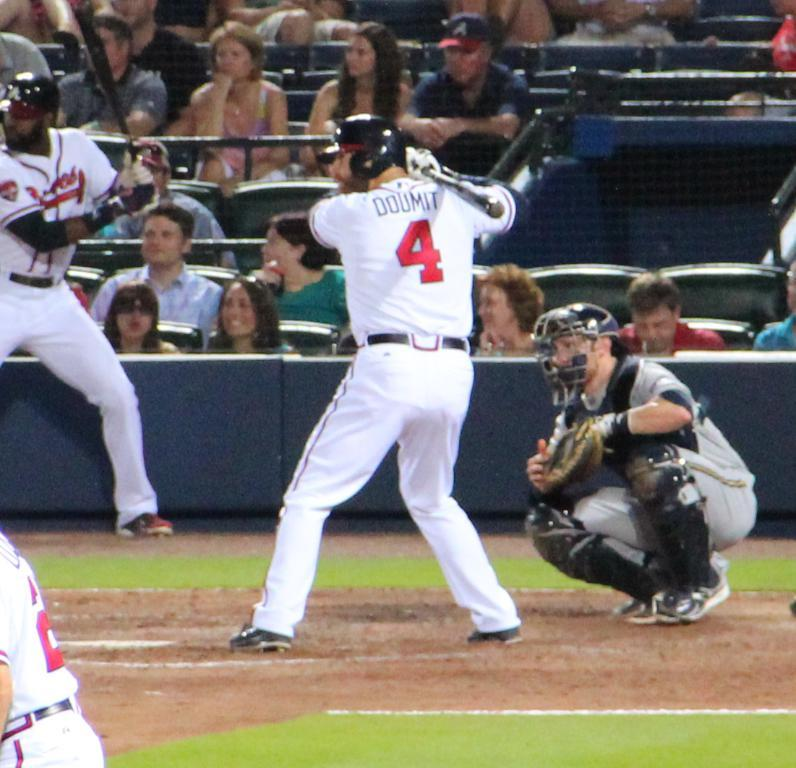<image>
Offer a succinct explanation of the picture presented. a player with the number 4 on their jersey 